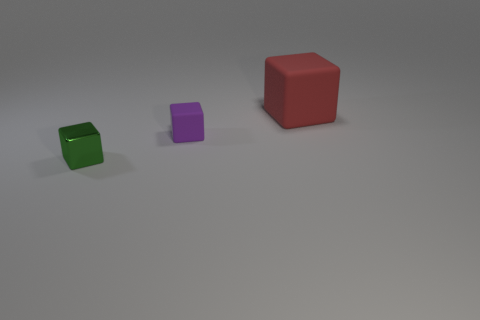Add 1 large brown spheres. How many objects exist? 4 Subtract all small cubes. How many cubes are left? 1 Subtract 1 blocks. How many blocks are left? 2 Subtract all big red objects. Subtract all red things. How many objects are left? 1 Add 1 metal blocks. How many metal blocks are left? 2 Add 1 small green rubber objects. How many small green rubber objects exist? 1 Subtract 1 red blocks. How many objects are left? 2 Subtract all yellow cubes. Subtract all brown balls. How many cubes are left? 3 